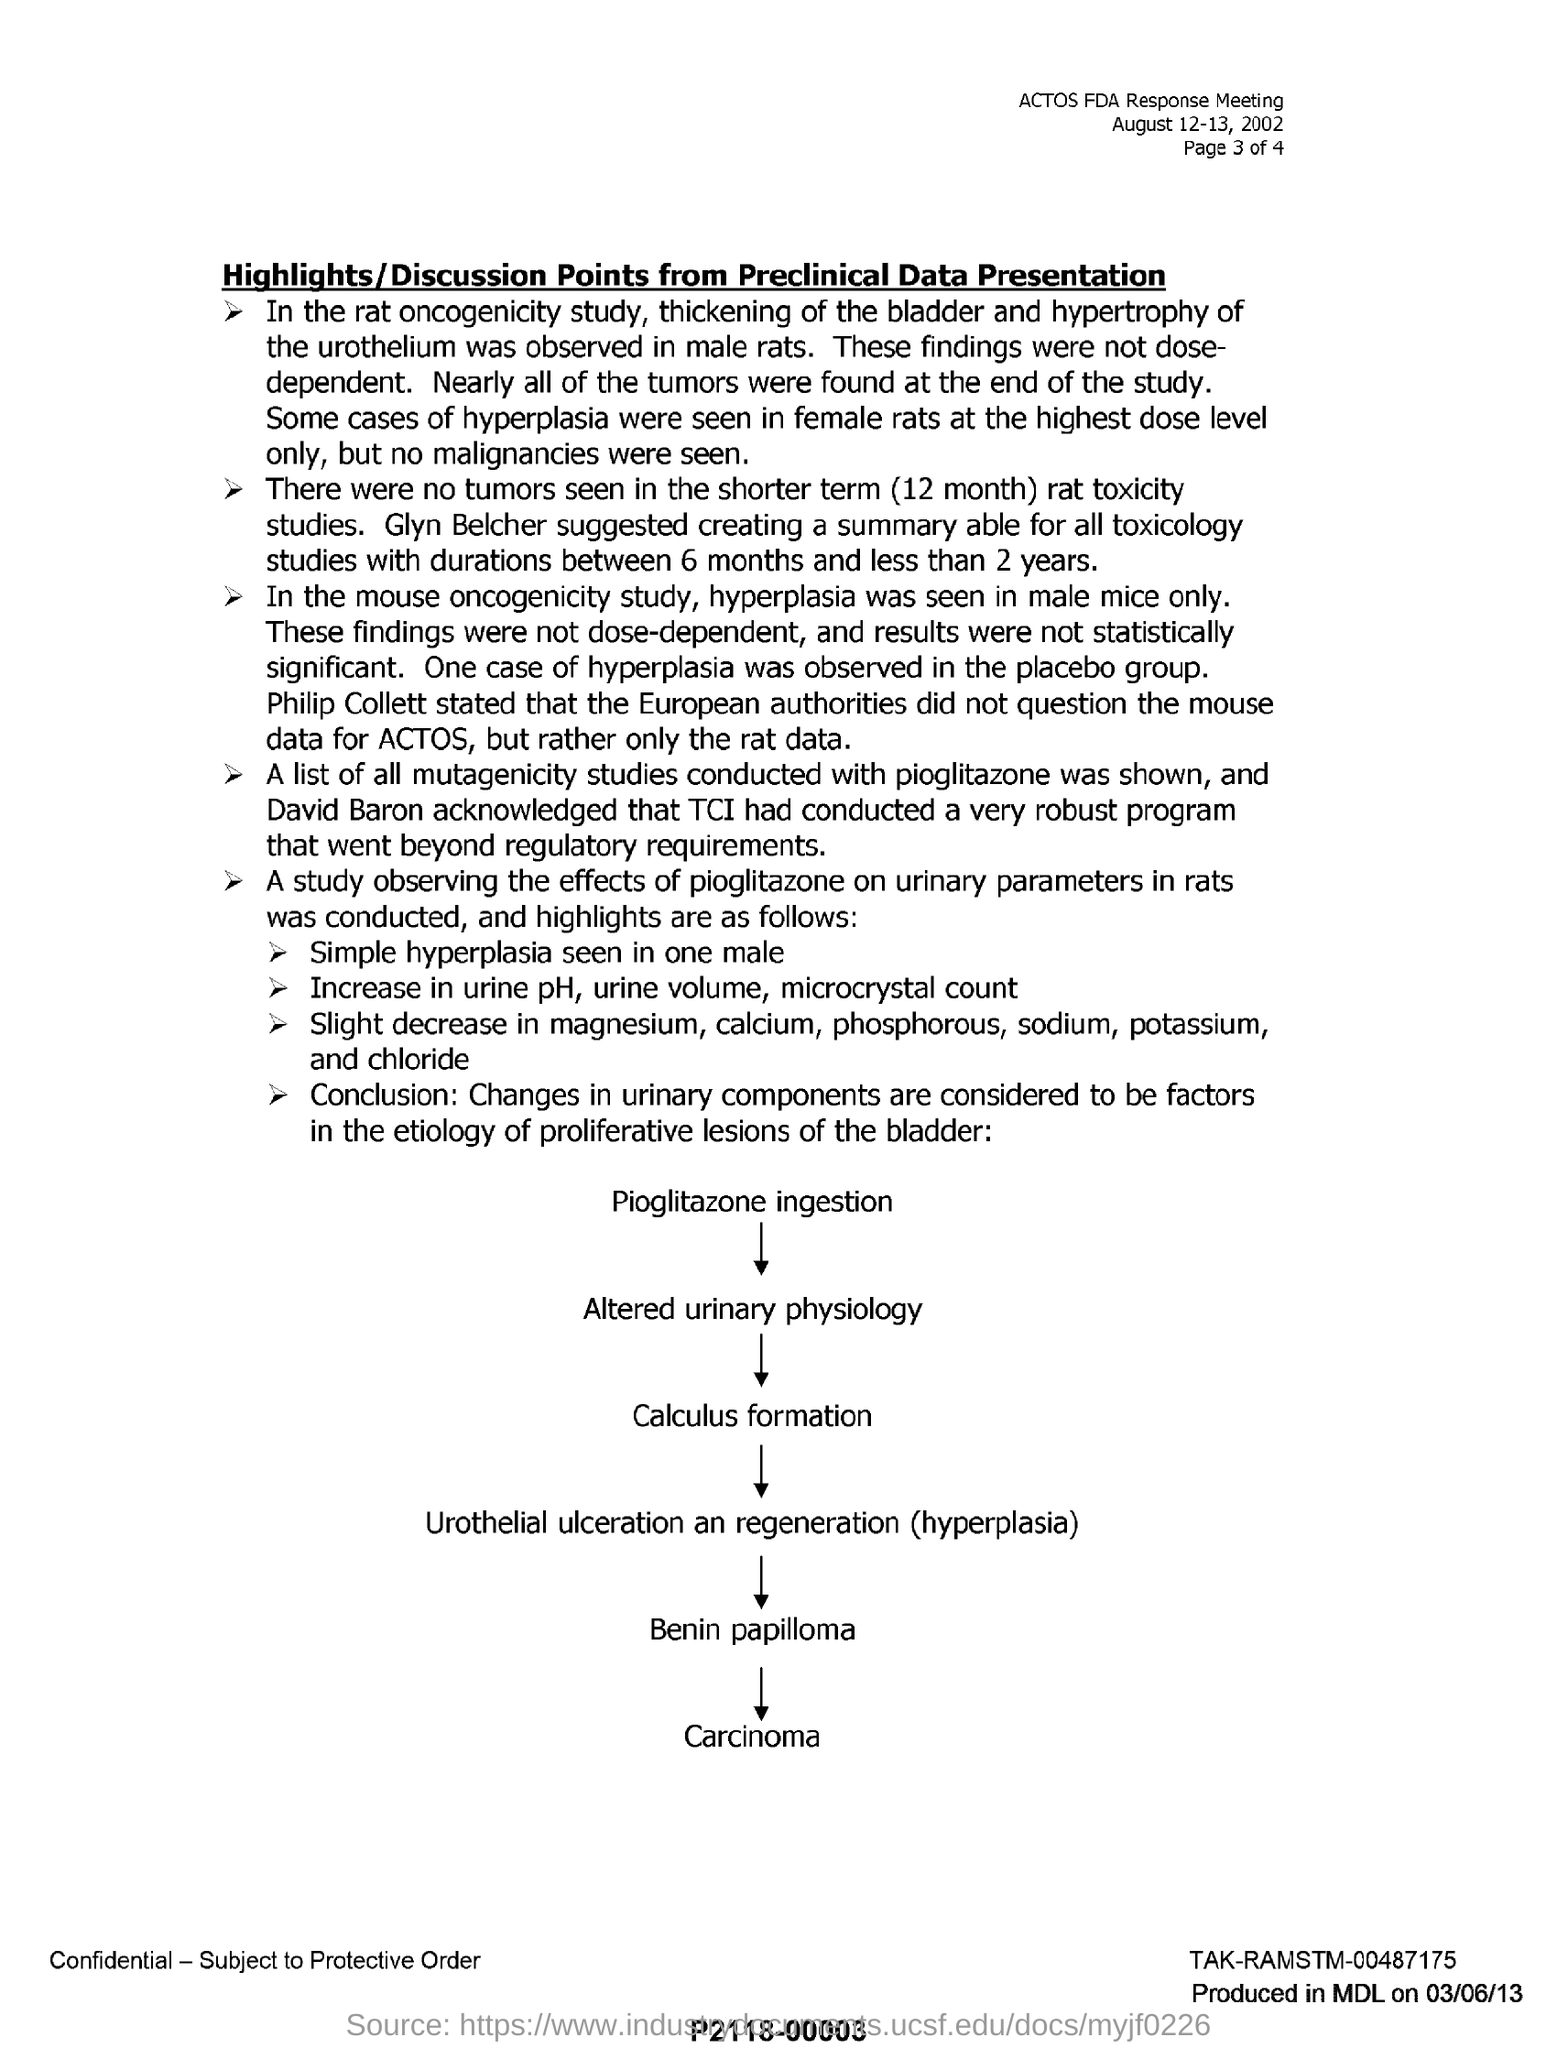In the rat oncogenicity study, what was observed in male rats?
Give a very brief answer. Thickening of the bladder and hypertrophy of the urothelium. What is the time span where no tumors are seen?
Your answer should be very brief. Shorter term (12 month). According to mouse oncogenicity study, what was seen male mice only?
Your answer should be compact. Hyperplasia. Who conducted robust program?
Your answer should be very brief. TCI. 